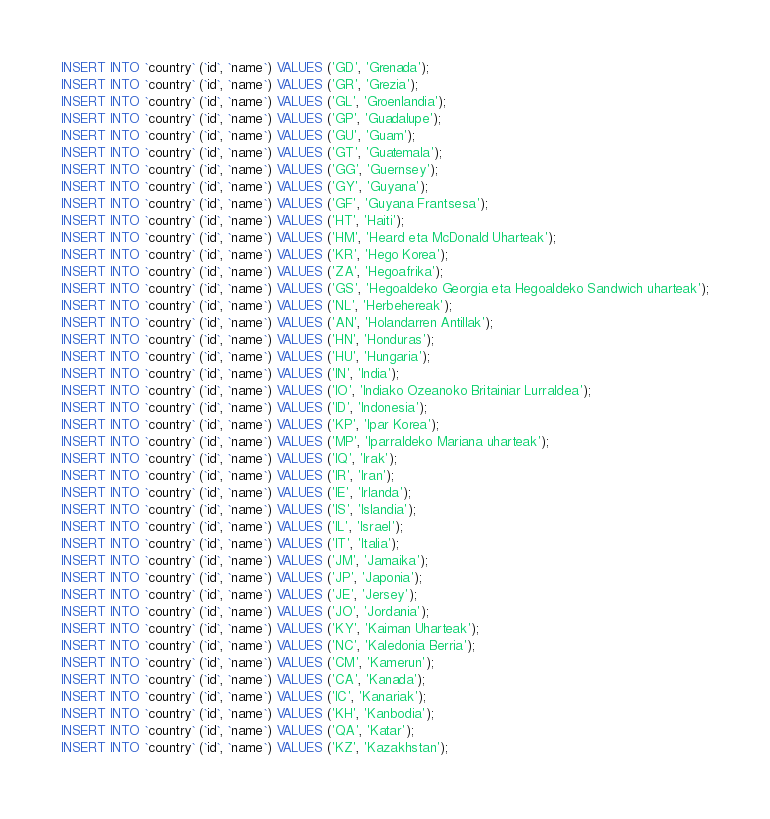<code> <loc_0><loc_0><loc_500><loc_500><_SQL_>INSERT INTO `country` (`id`, `name`) VALUES ('GD', 'Grenada');
INSERT INTO `country` (`id`, `name`) VALUES ('GR', 'Grezia');
INSERT INTO `country` (`id`, `name`) VALUES ('GL', 'Groenlandia');
INSERT INTO `country` (`id`, `name`) VALUES ('GP', 'Guadalupe');
INSERT INTO `country` (`id`, `name`) VALUES ('GU', 'Guam');
INSERT INTO `country` (`id`, `name`) VALUES ('GT', 'Guatemala');
INSERT INTO `country` (`id`, `name`) VALUES ('GG', 'Guernsey');
INSERT INTO `country` (`id`, `name`) VALUES ('GY', 'Guyana');
INSERT INTO `country` (`id`, `name`) VALUES ('GF', 'Guyana Frantsesa');
INSERT INTO `country` (`id`, `name`) VALUES ('HT', 'Haiti');
INSERT INTO `country` (`id`, `name`) VALUES ('HM', 'Heard eta McDonald Uharteak');
INSERT INTO `country` (`id`, `name`) VALUES ('KR', 'Hego Korea');
INSERT INTO `country` (`id`, `name`) VALUES ('ZA', 'Hegoafrika');
INSERT INTO `country` (`id`, `name`) VALUES ('GS', 'Hegoaldeko Georgia eta Hegoaldeko Sandwich uharteak');
INSERT INTO `country` (`id`, `name`) VALUES ('NL', 'Herbehereak');
INSERT INTO `country` (`id`, `name`) VALUES ('AN', 'Holandarren Antillak');
INSERT INTO `country` (`id`, `name`) VALUES ('HN', 'Honduras');
INSERT INTO `country` (`id`, `name`) VALUES ('HU', 'Hungaria');
INSERT INTO `country` (`id`, `name`) VALUES ('IN', 'India');
INSERT INTO `country` (`id`, `name`) VALUES ('IO', 'Indiako Ozeanoko Britainiar Lurraldea');
INSERT INTO `country` (`id`, `name`) VALUES ('ID', 'Indonesia');
INSERT INTO `country` (`id`, `name`) VALUES ('KP', 'Ipar Korea');
INSERT INTO `country` (`id`, `name`) VALUES ('MP', 'Iparraldeko Mariana uharteak');
INSERT INTO `country` (`id`, `name`) VALUES ('IQ', 'Irak');
INSERT INTO `country` (`id`, `name`) VALUES ('IR', 'Iran');
INSERT INTO `country` (`id`, `name`) VALUES ('IE', 'Irlanda');
INSERT INTO `country` (`id`, `name`) VALUES ('IS', 'Islandia');
INSERT INTO `country` (`id`, `name`) VALUES ('IL', 'Israel');
INSERT INTO `country` (`id`, `name`) VALUES ('IT', 'Italia');
INSERT INTO `country` (`id`, `name`) VALUES ('JM', 'Jamaika');
INSERT INTO `country` (`id`, `name`) VALUES ('JP', 'Japonia');
INSERT INTO `country` (`id`, `name`) VALUES ('JE', 'Jersey');
INSERT INTO `country` (`id`, `name`) VALUES ('JO', 'Jordania');
INSERT INTO `country` (`id`, `name`) VALUES ('KY', 'Kaiman Uharteak');
INSERT INTO `country` (`id`, `name`) VALUES ('NC', 'Kaledonia Berria');
INSERT INTO `country` (`id`, `name`) VALUES ('CM', 'Kamerun');
INSERT INTO `country` (`id`, `name`) VALUES ('CA', 'Kanada');
INSERT INTO `country` (`id`, `name`) VALUES ('IC', 'Kanariak');
INSERT INTO `country` (`id`, `name`) VALUES ('KH', 'Kanbodia');
INSERT INTO `country` (`id`, `name`) VALUES ('QA', 'Katar');
INSERT INTO `country` (`id`, `name`) VALUES ('KZ', 'Kazakhstan');</code> 